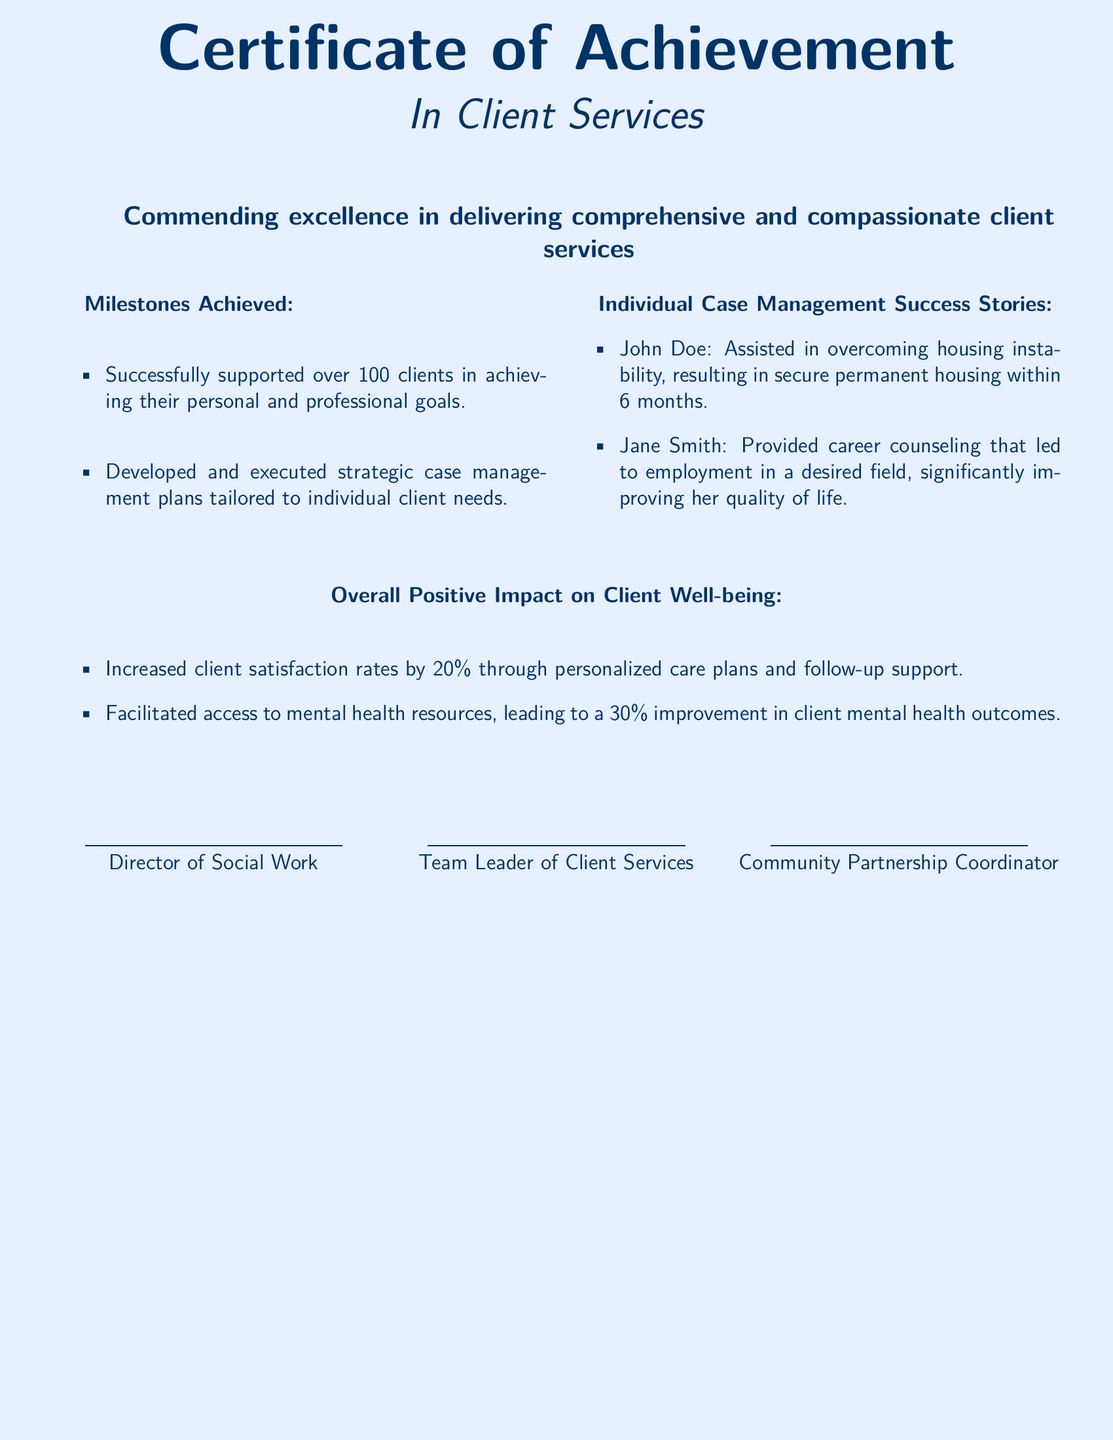What is the title of the certificate? The title is clearly stated at the top of the document and is "Certificate of Achievement."
Answer: Certificate of Achievement In which field is the certificate awarded? The field of recognition is indicated immediately following the title, which specifies "In Client Services."
Answer: In Client Services How many clients were successfully supported? The number of clients supported can be found in the milestones section, which states "over 100 clients."
Answer: over 100 clients What percentage increase in client satisfaction rates is mentioned? The document states the client satisfaction increase in the positive impact section, which is "20%."
Answer: 20% Who is the Director of Social Work? The document provides a space for signing, indicating the Director of Social Work's name would be written there.
Answer: [Director's Name] What was a significant outcome for John Doe? The success story for John Doe concludes with him obtaining "secure permanent housing within 6 months."
Answer: secure permanent housing within 6 months What is the item that describes the overall positive impact? The section heading describes the positive influence, which is clearly written as "Overall Positive Impact on Client Well-being."
Answer: Overall Positive Impact on Client Well-being What is one of the milestones achieved according to the document? A specific milestone is listed under the achievements, stating the development of "strategic case management plans."
Answer: strategic case management plans How many case management success stories are mentioned? The document lists a total of "two" individual case management success stories.
Answer: two 